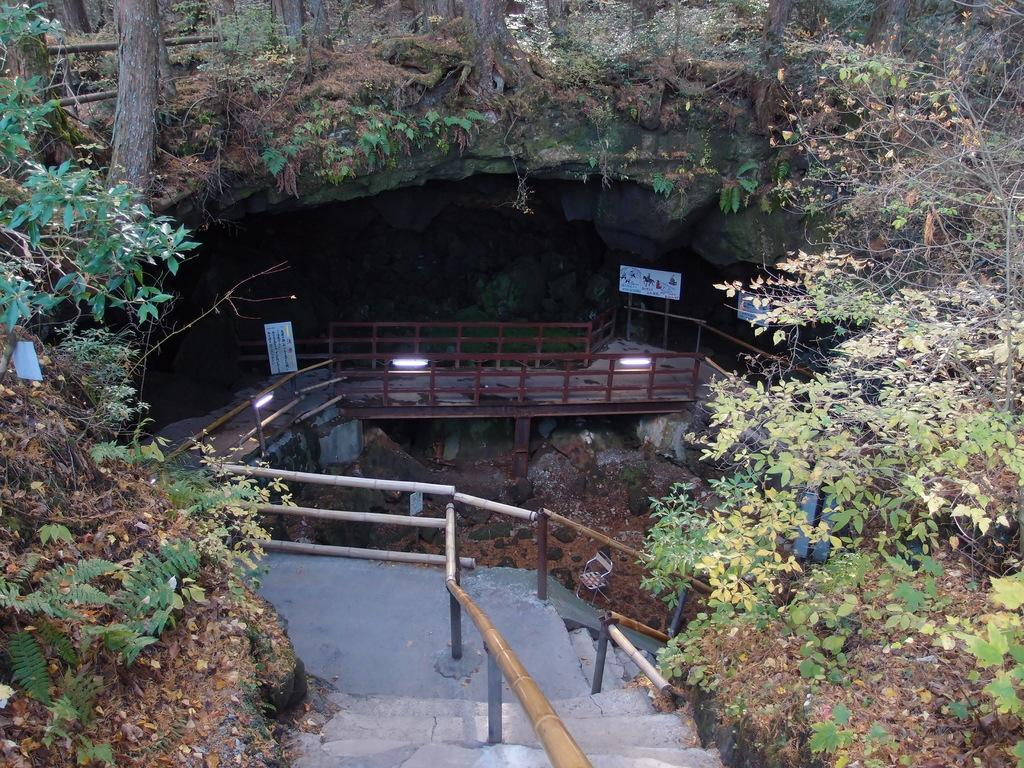What type of structure can be seen in the image? There is railing in the image. What can be found near the railing? There is a planter in the image. What is providing illumination in the image? There are lights in the image. What material is present in the image? There are boards in the image. What type of natural element is visible in the image? There are rocks in the image. What type of agreement is being signed in the image? There is no indication of an agreement or signing in the image; it features railing, a planter, lights, boards, and rocks. What kind of pets are visible in the image? There are no pets present in the image. 